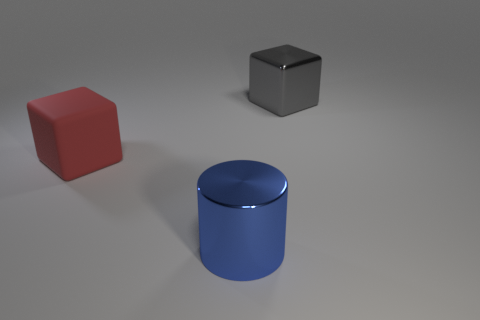What number of big gray things are the same shape as the blue object?
Offer a terse response. 0. What is the material of the block that is behind the big red matte cube?
Offer a very short reply. Metal. Are there fewer big blue objects right of the large blue shiny cylinder than large gray metallic cubes?
Provide a succinct answer. Yes. Is the red rubber object the same shape as the gray object?
Ensure brevity in your answer.  Yes. Is there any other thing that is the same shape as the big red thing?
Give a very brief answer. Yes. Are there any small gray matte balls?
Keep it short and to the point. No. There is a large blue shiny thing; is its shape the same as the thing behind the red rubber thing?
Your answer should be very brief. No. There is a big block that is on the right side of the big block that is to the left of the gray shiny block; what is it made of?
Offer a very short reply. Metal. The rubber block has what color?
Your response must be concise. Red. There is a thing to the right of the big blue cylinder; is it the same color as the large rubber cube that is to the left of the large blue shiny cylinder?
Your answer should be very brief. No. 